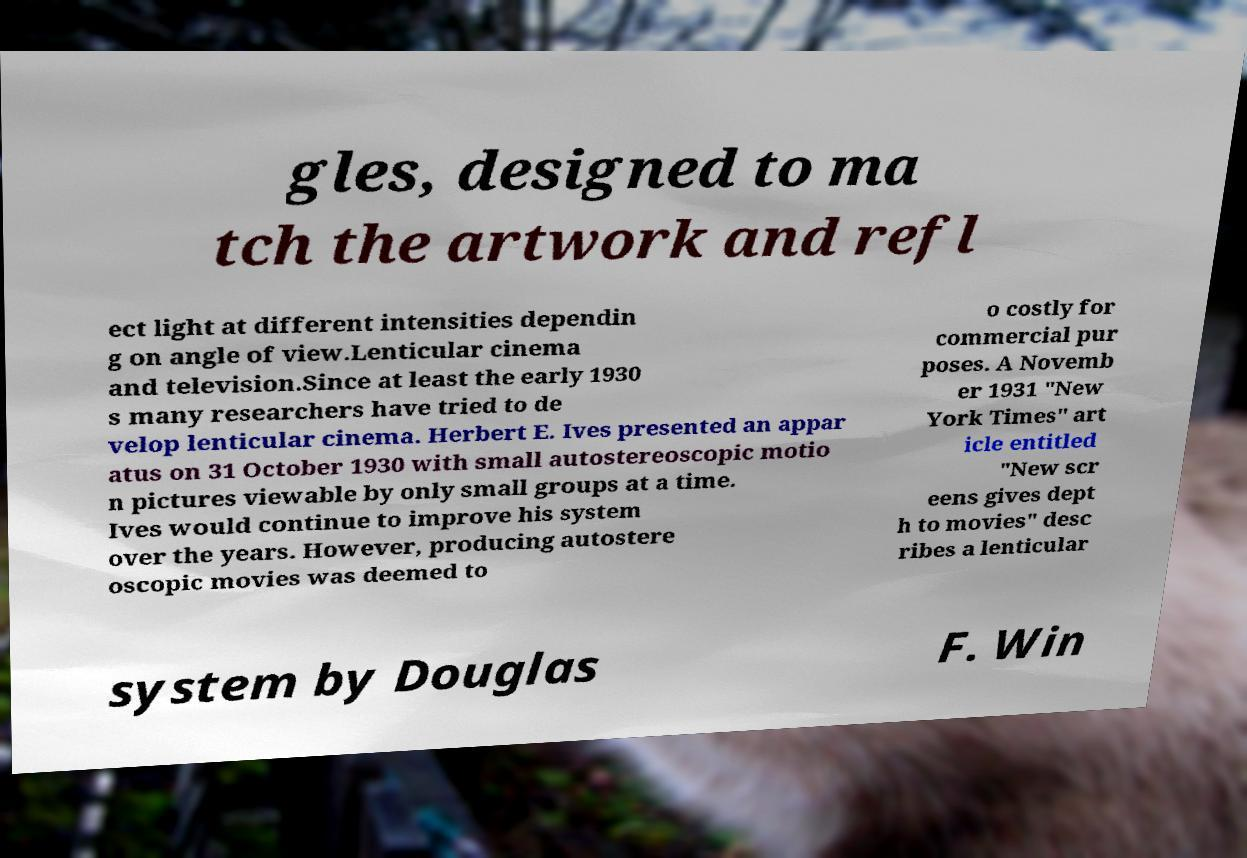Can you accurately transcribe the text from the provided image for me? gles, designed to ma tch the artwork and refl ect light at different intensities dependin g on angle of view.Lenticular cinema and television.Since at least the early 1930 s many researchers have tried to de velop lenticular cinema. Herbert E. Ives presented an appar atus on 31 October 1930 with small autostereoscopic motio n pictures viewable by only small groups at a time. Ives would continue to improve his system over the years. However, producing autostere oscopic movies was deemed to o costly for commercial pur poses. A Novemb er 1931 "New York Times" art icle entitled "New scr eens gives dept h to movies" desc ribes a lenticular system by Douglas F. Win 